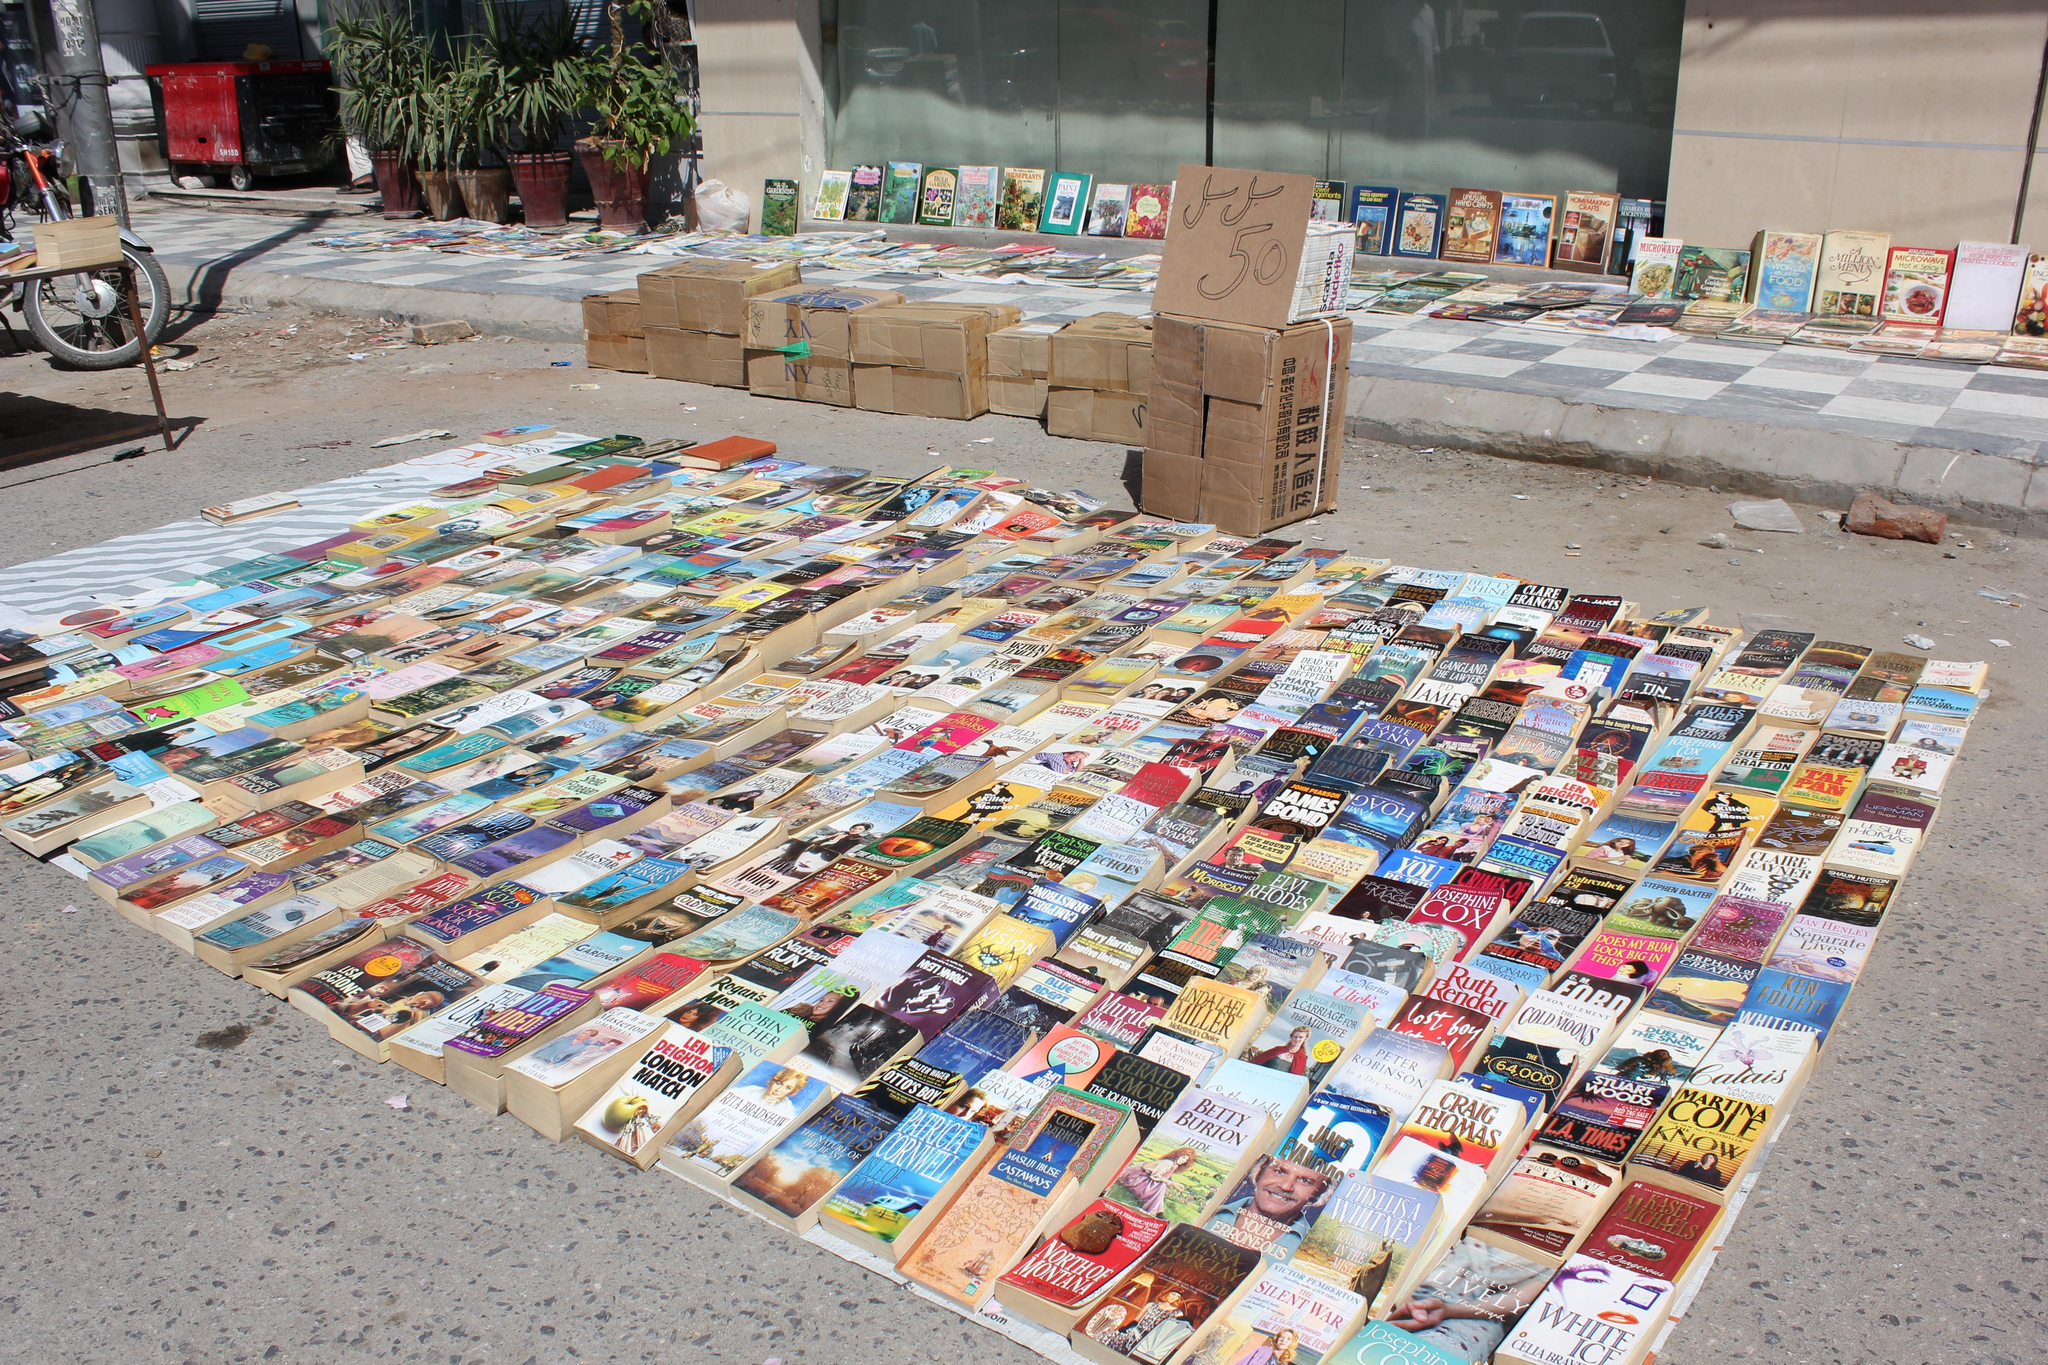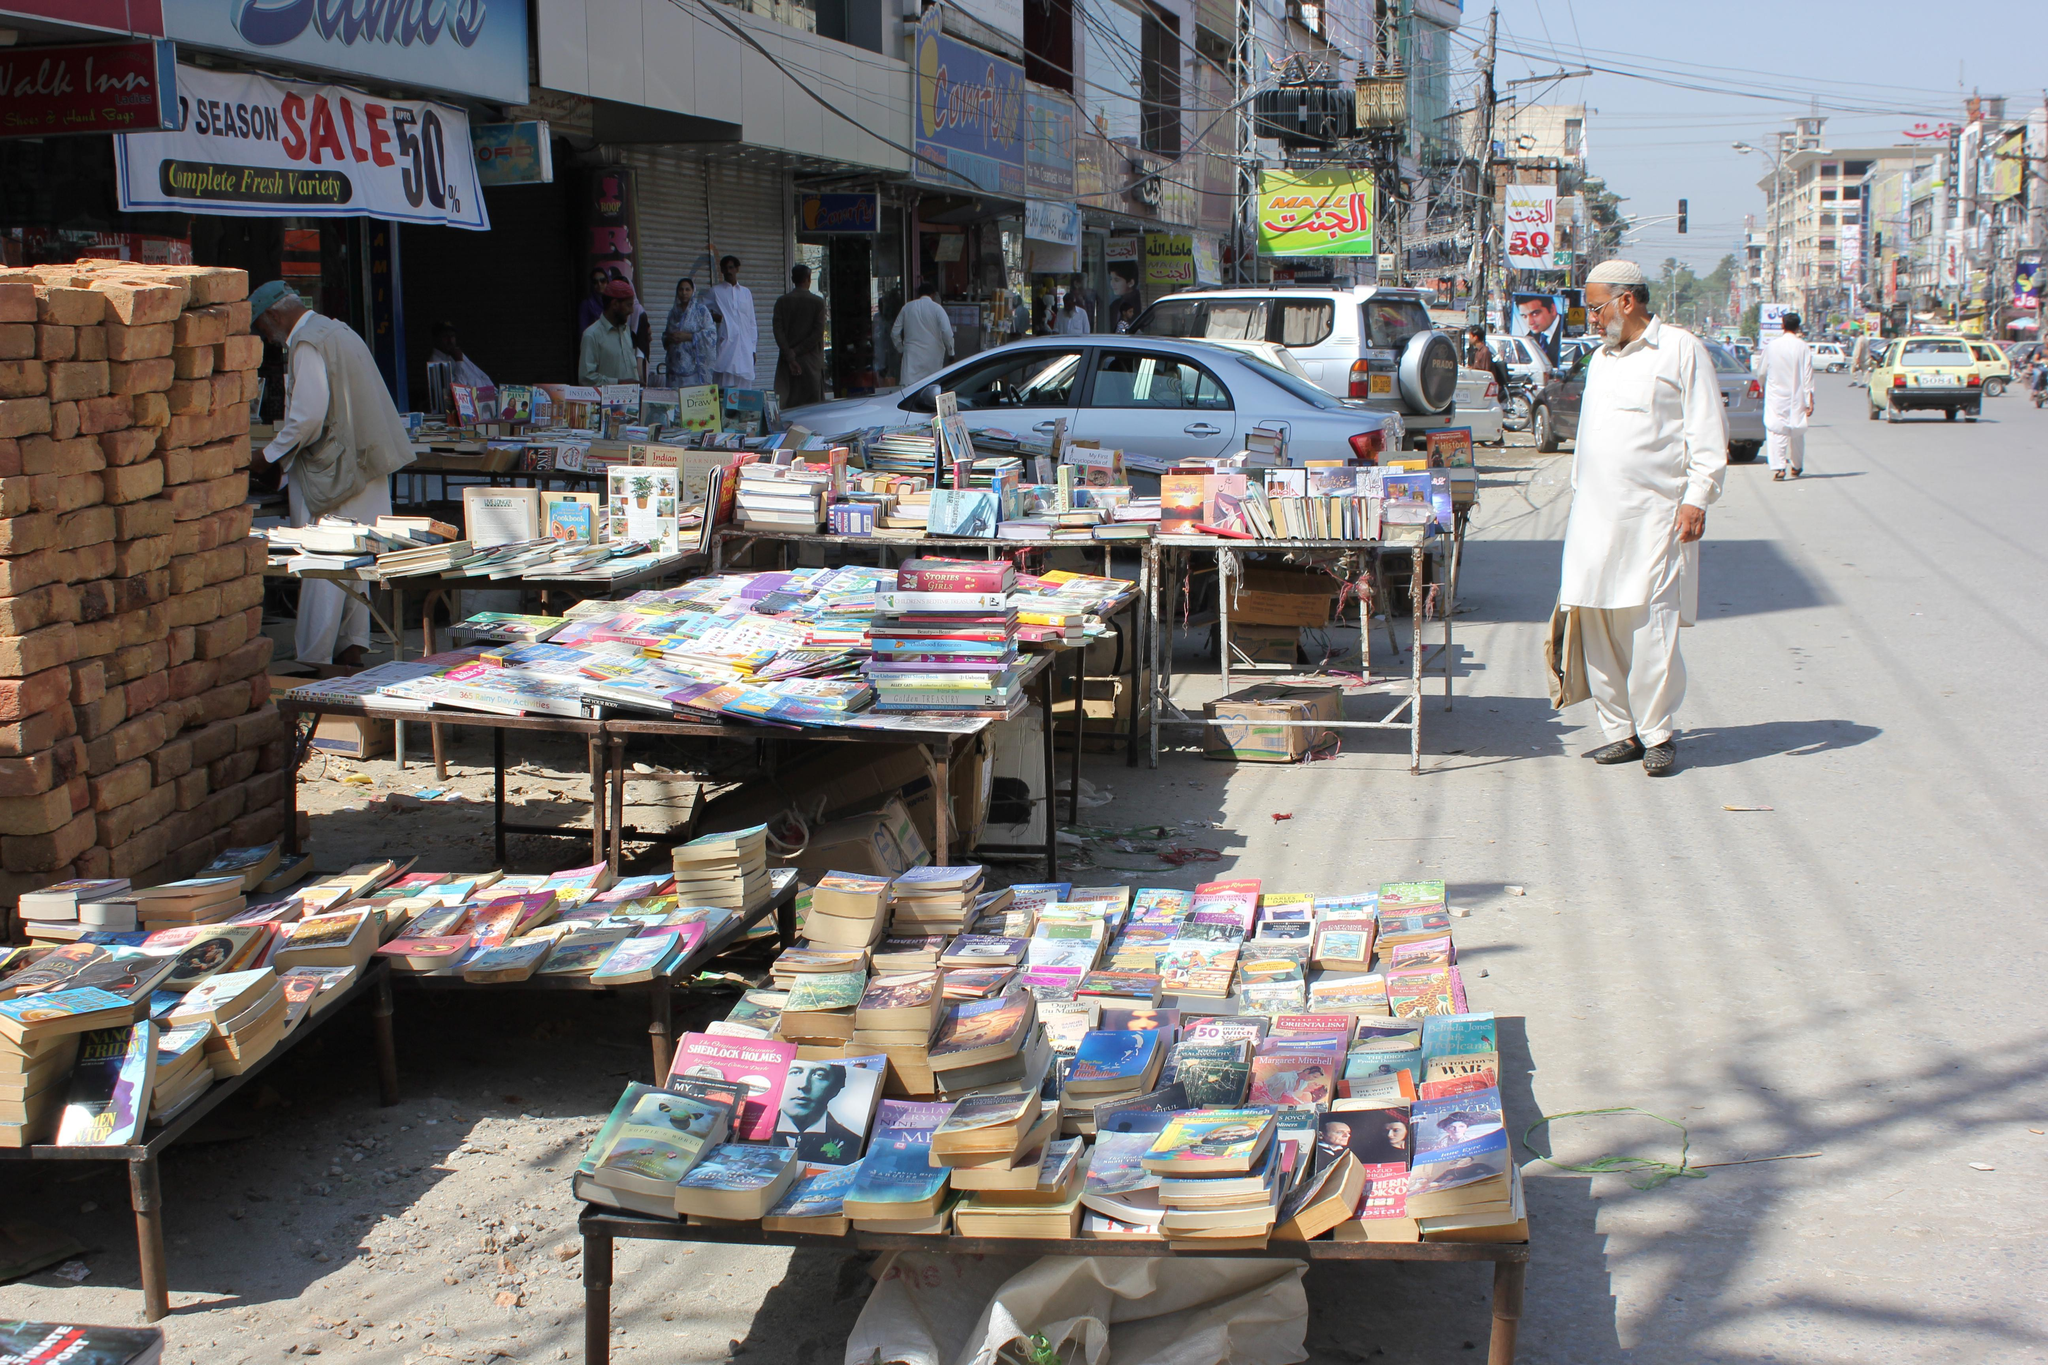The first image is the image on the left, the second image is the image on the right. Evaluate the accuracy of this statement regarding the images: "One woman is wearing a hijab while shopping for books.". Is it true? Answer yes or no. No. The first image is the image on the left, the second image is the image on the right. Analyze the images presented: Is the assertion "There are products on the asphalt road in both images." valid? Answer yes or no. Yes. 